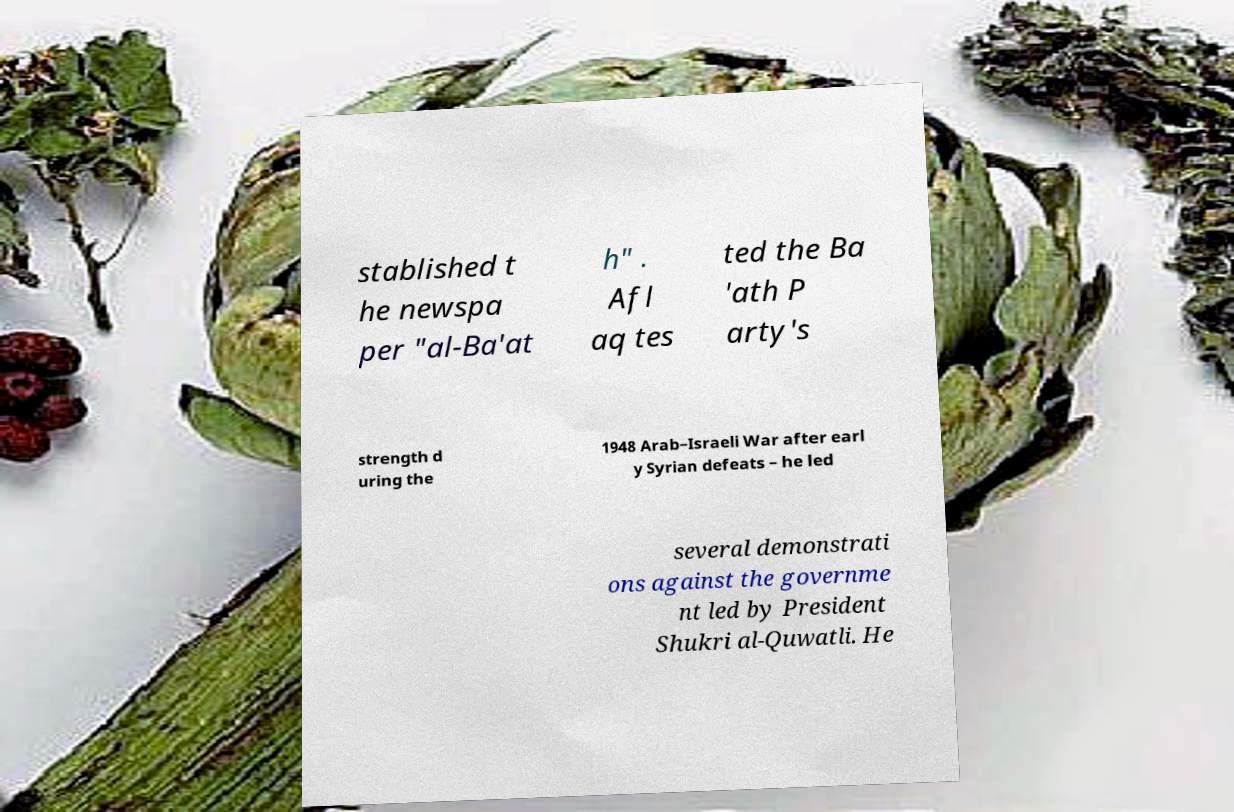What messages or text are displayed in this image? I need them in a readable, typed format. stablished t he newspa per "al-Ba'at h" . Afl aq tes ted the Ba 'ath P arty's strength d uring the 1948 Arab–Israeli War after earl y Syrian defeats – he led several demonstrati ons against the governme nt led by President Shukri al-Quwatli. He 